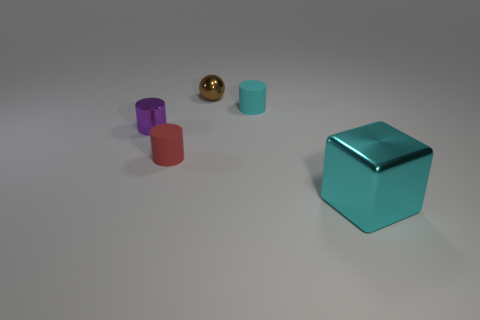Add 3 yellow metallic balls. How many objects exist? 8 Subtract all small cyan matte cylinders. How many cylinders are left? 2 Subtract 3 cylinders. How many cylinders are left? 0 Subtract all cyan cylinders. How many cylinders are left? 2 Subtract all cylinders. How many objects are left? 2 Subtract all blue cylinders. Subtract all brown balls. How many cylinders are left? 3 Subtract all shiny spheres. Subtract all brown objects. How many objects are left? 3 Add 5 small rubber things. How many small rubber things are left? 7 Add 2 tiny purple cylinders. How many tiny purple cylinders exist? 3 Subtract 0 yellow balls. How many objects are left? 5 